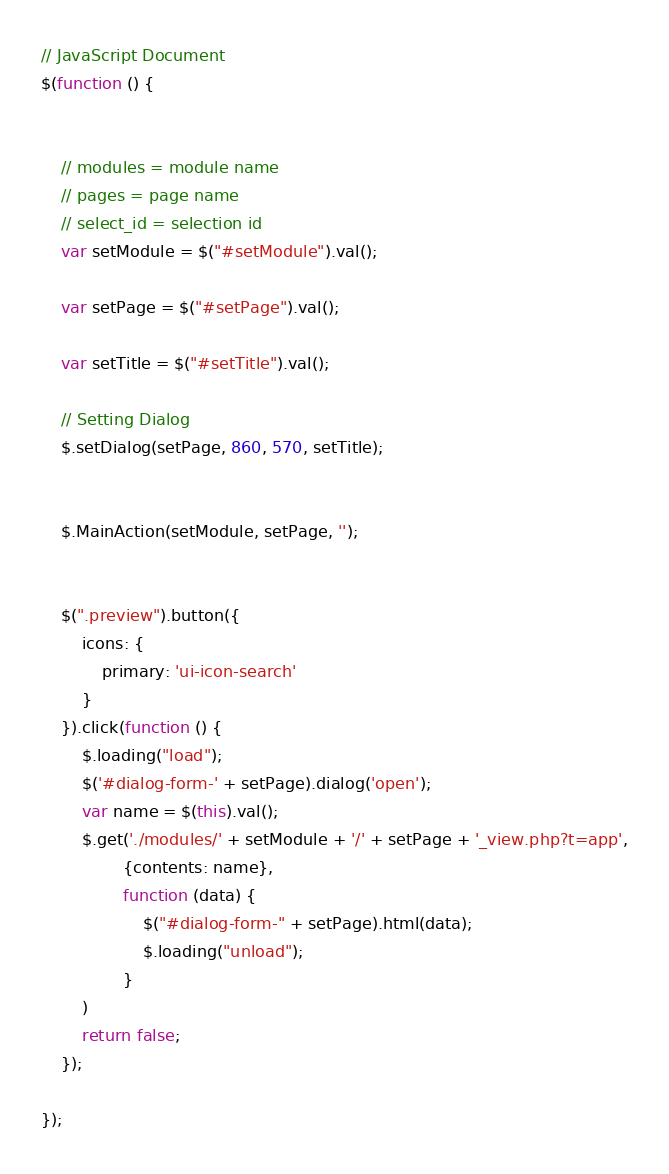<code> <loc_0><loc_0><loc_500><loc_500><_JavaScript_>// JavaScript Document
$(function () {


    // modules = module name
    // pages = page name
    // select_id = selection id
    var setModule = $("#setModule").val();

    var setPage = $("#setPage").val();

    var setTitle = $("#setTitle").val();

    // Setting Dialog
    $.setDialog(setPage, 860, 570, setTitle);


    $.MainAction(setModule, setPage, '');


    $(".preview").button({
        icons: {
            primary: 'ui-icon-search'
        }
    }).click(function () {
        $.loading("load");
        $('#dialog-form-' + setPage).dialog('open');
        var name = $(this).val();
        $.get('./modules/' + setModule + '/' + setPage + '_view.php?t=app',
                {contents: name},
                function (data) {
                    $("#dialog-form-" + setPage).html(data);
                    $.loading("unload");
                }
        )
        return false;
    });

});

</code> 